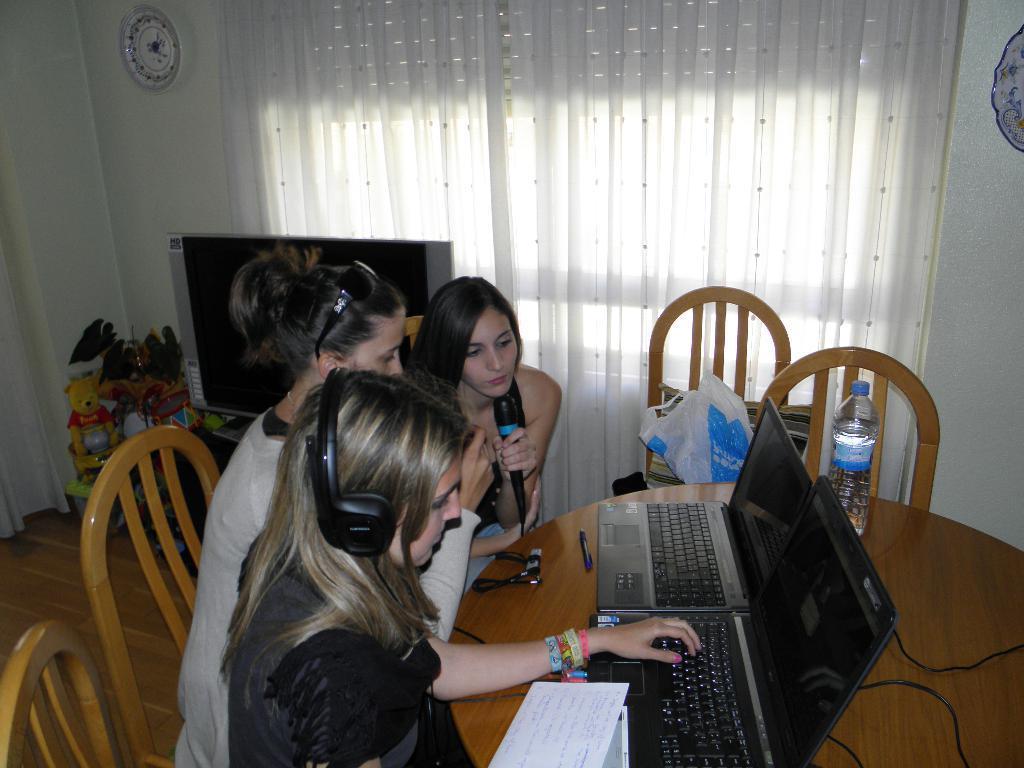Describe this image in one or two sentences. In this picture we can see three woman sitting on chair where one is holding mic and looking at laptop and other is typing on keyboard where this laptops are placed on table along with bottles, wire and beside to this table we have chairs, television, toys, curtains to window, clock on wall. 